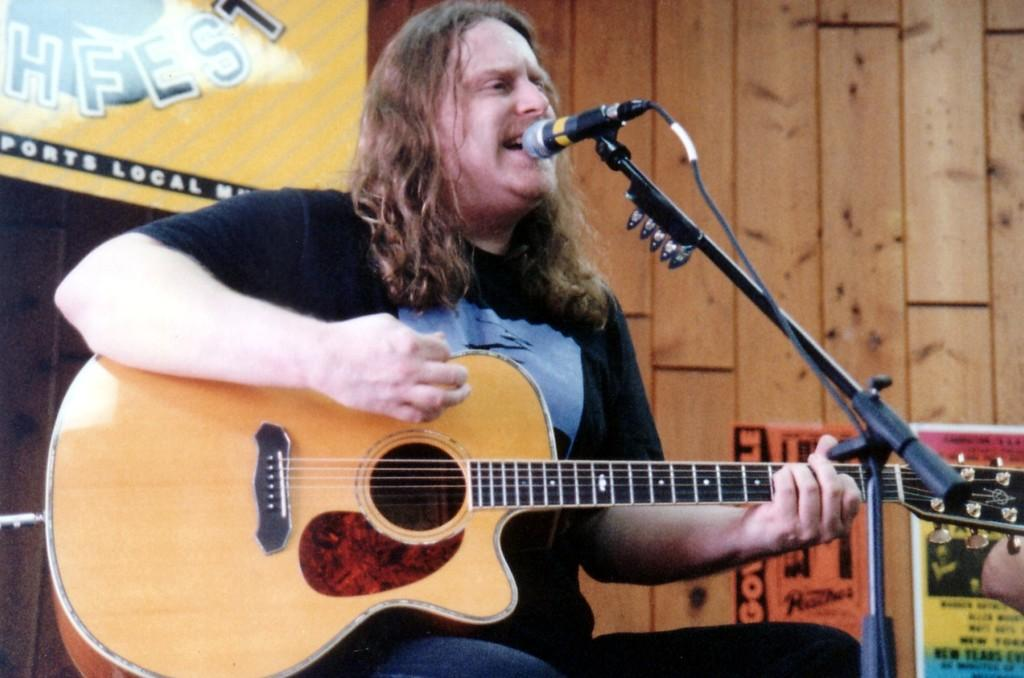Who is the main subject in the image? There is a person in the image. What is the person doing in the image? The person is sitting and playing a guitar. What object is in front of the person? There is a microphone in front of the person. What can be seen behind the person? There is a wall behind the person. What type of support can be seen holding up the clover in the image? There is no clover present in the image, and therefore no support for it. 